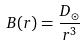<formula> <loc_0><loc_0><loc_500><loc_500>B ( r ) = \frac { D _ { \odot } } { r ^ { 3 } }</formula> 